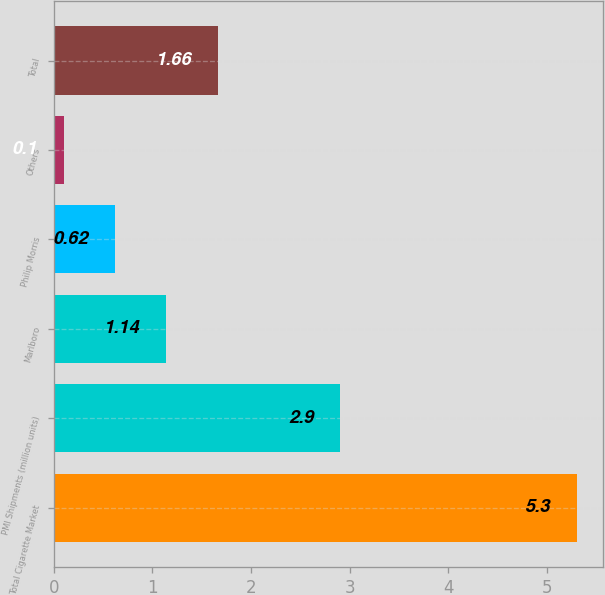<chart> <loc_0><loc_0><loc_500><loc_500><bar_chart><fcel>Total Cigarette Market<fcel>PMI Shipments (million units)<fcel>Marlboro<fcel>Philip Morris<fcel>Others<fcel>Total<nl><fcel>5.3<fcel>2.9<fcel>1.14<fcel>0.62<fcel>0.1<fcel>1.66<nl></chart> 